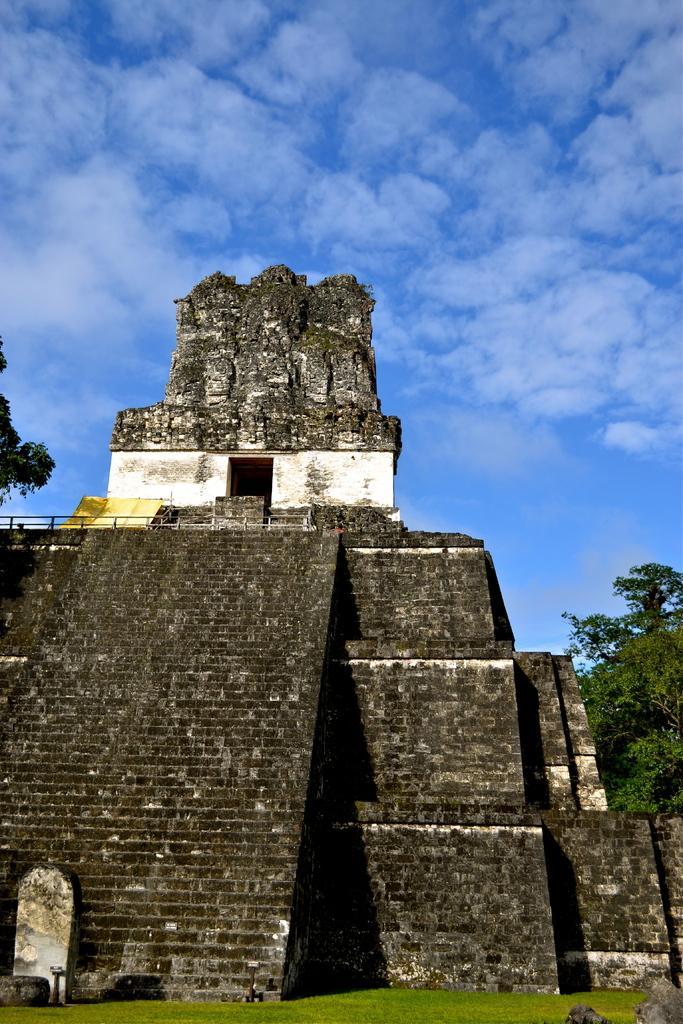How would you summarize this image in a sentence or two? In this picture I can see monument. I can see tree on the right side. I can see there are clouds in the sky. 